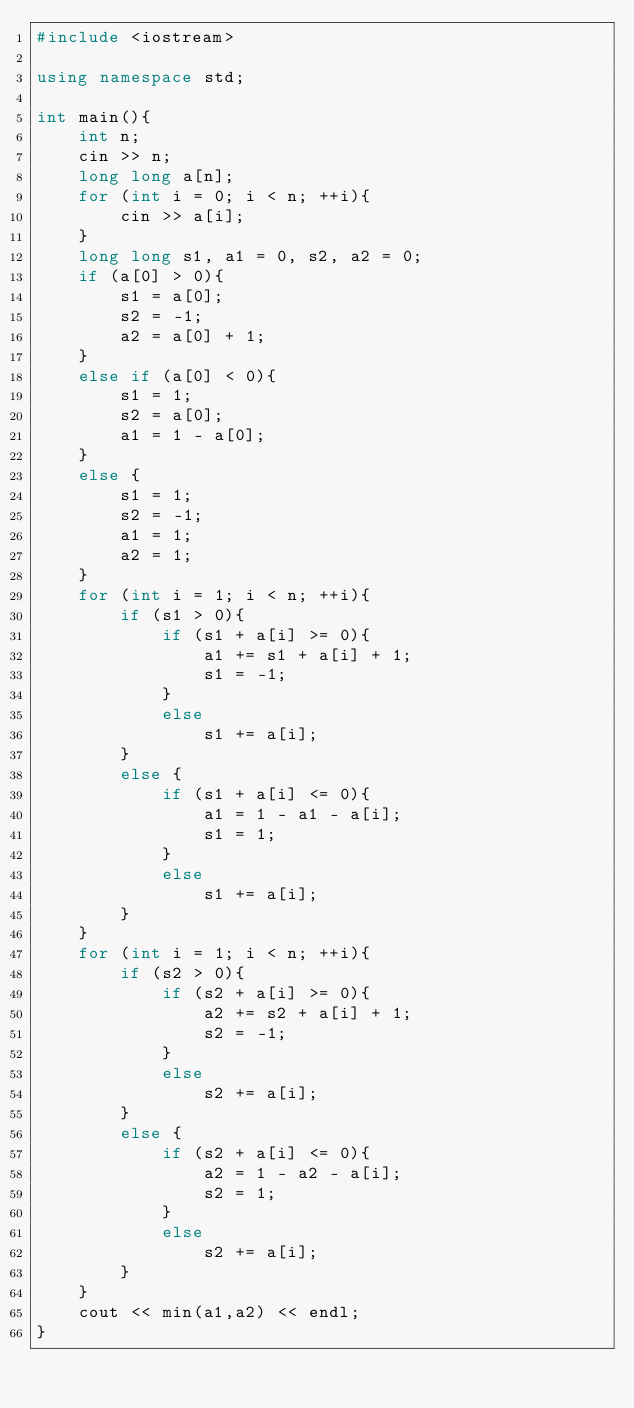<code> <loc_0><loc_0><loc_500><loc_500><_C++_>#include <iostream>

using namespace std;

int main(){
    int n;
    cin >> n;
    long long a[n];
    for (int i = 0; i < n; ++i){
        cin >> a[i];
    }
    long long s1, a1 = 0, s2, a2 = 0;
    if (a[0] > 0){
        s1 = a[0];
        s2 = -1;
        a2 = a[0] + 1;
    }
    else if (a[0] < 0){
        s1 = 1;
        s2 = a[0];
        a1 = 1 - a[0];
    }
    else {
        s1 = 1;
        s2 = -1;
        a1 = 1;
        a2 = 1;
    }
    for (int i = 1; i < n; ++i){
        if (s1 > 0){
            if (s1 + a[i] >= 0){
                a1 += s1 + a[i] + 1;
                s1 = -1;
            }
            else
                s1 += a[i];
        }
        else {
            if (s1 + a[i] <= 0){
                a1 = 1 - a1 - a[i];
                s1 = 1;
            }
            else
                s1 += a[i];
        }
    }
    for (int i = 1; i < n; ++i){
        if (s2 > 0){
            if (s2 + a[i] >= 0){
                a2 += s2 + a[i] + 1;
                s2 = -1;
            }
            else
                s2 += a[i];
        }
        else {
            if (s2 + a[i] <= 0){
                a2 = 1 - a2 - a[i];
                s2 = 1;
            }
            else
                s2 += a[i];
        }
    }
    cout << min(a1,a2) << endl;
}</code> 